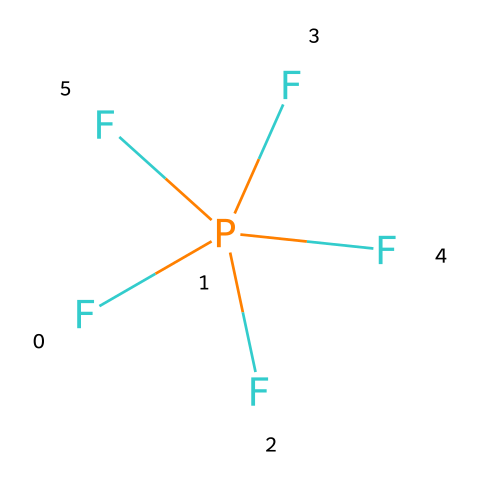How many fluorine atoms are present in phosphorus pentafluoride? The SMILES representation indicates five F fluorine atoms, which are directly related to the phosphorus atom.
Answer: five What is the central atom in phosphorus pentafluoride? The structure reveals phosphorus is the central atom, surrounded by five fluorine atoms, as indicated in the SMILES.
Answer: phosphorus How many bonds does phosphorus form in phosphorus pentafluoride? Each fluorine atom is linked to phosphorus through a single bond, resulting in five bonds formed by the phosphorus atom.
Answer: five Is phosphorus pentafluoride a hypervalent compound? The presence of more than four bonds around the phosphorus atom demonstrates that it has more than an octet of electrons, confirming it as hypervalent.
Answer: yes What is the oxidation state of phosphorus in phosphorus pentafluoride? In this compound, phosphorus has an oxidation state of +5, as each fluorine atom contributes a -1 charge, totaling -5, leading to a neutral overall charge.
Answer: +5 Can you name the type of bond present between phosphorus and fluorine in phosphorus pentafluoride? The bonds between phosphorus and fluorine are covalent bonds, as they involve sharing electrons between these two nonmetals.
Answer: covalent 